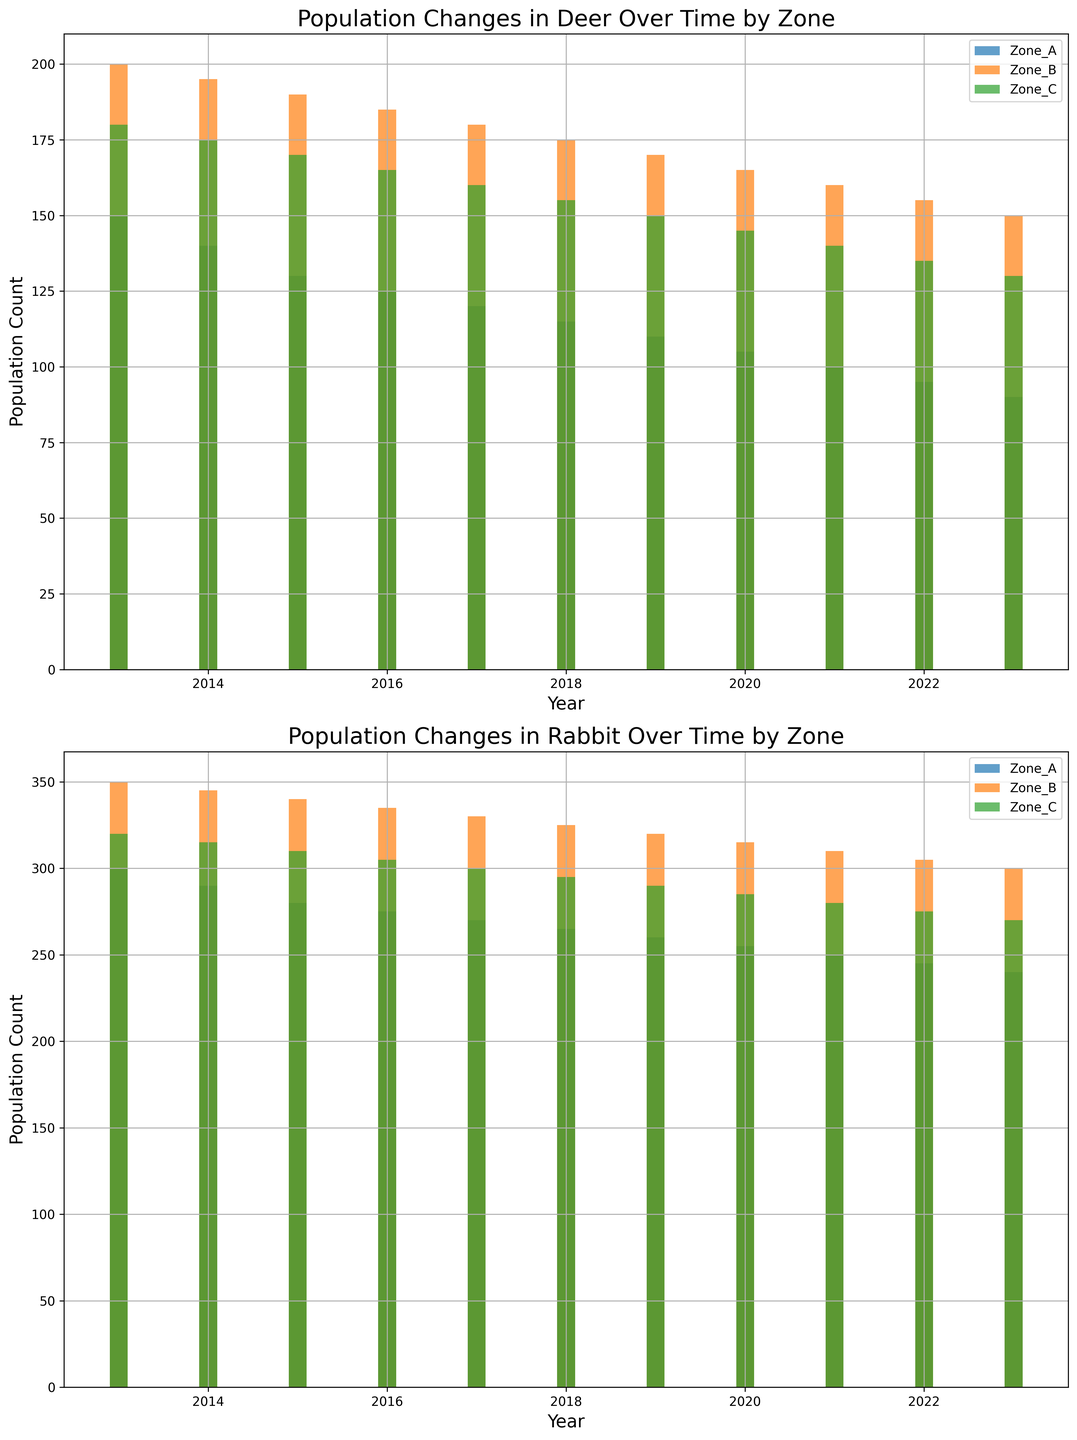What is the trend in the deer population in Zone A over the 10-year period? To determine the trend, we look at the bar heights for Zone A over the 10-year period from 2013 to 2023. The height of the bars decreases each year, indicating a consistent downward trend in the deer population.
Answer: Downward trend How does the rabbit population in Zone B in 2023 compare to that in 2013? By comparing the bar heights for the rabbit population in Zone B in 2013 and 2023, we see that the height of the bar in 2023 (300) is slightly lower than that in 2013 (350), indicating a decrease.
Answer: Decreased Which industrial zone has the highest population count for deer in 2020? By looking at the height of the bars for deer in all three zones for the year 2020, Zone B has the highest bar, indicating it has the highest population count.
Answer: Zone B What is the average population count of rabbits in Zone A over the 10-year period? Add all the population counts for rabbits in Zone A from 2013 to 2023, then divide by the number of years (10): (300+290+280+275+270+265+260+255+250+245+240)/11 = 2700 / 11 = 245.45
Answer: 272.5 Has the deer population in Zone C ever increased from one year to the next? We look at the bar heights for deer in Zone C from each year to the next. They consistently decrease, indicating that the population has not increased from one year to the next.
Answer: No Which species in Zone B had a greater decrease in population count over the 10-year period? Calculate the difference in starting (2013) and ending (2023) counts for deer and rabbits in Zone B. For deer: 200 - 150 = 50; for rabbits: 350 - 300 = 50. Both species in Zone B had an equal decrease of 50 in their population counts.
Answer: Deer and Rabbit (equal decrease) How did the population counts for deer change across all zones from 2013 to 2023? Combining the population counts of deer for each year across all three zones for 2013 and 2023, respectively: 150+200+180 = 530 (2013) and 90+150+130 = 370 (2023). The deer population decreased by 530 - 370 = 160.
Answer: Decreased by 160 Are there any years where the population counts for deer in Zone B and Zone C were equal? Compare the heights of the bars for deer in both zones for each year. There aren't any years where the bars (population counts) are equal.
Answer: No Which species and zone combination shows the least population decrease over the 10 years? Calculate the initial and final counts and find the difference for all combinations. The smallest decrease over 10 years is seen in rabbit, Zone A: 300 - 240 = 60.
Answer: Rabbit, Zone A What is the difference in population count for rabbits in Zone C between the highest and lowest years? Identify the highest and lowest population count years for rabbits in Zone C. The highest is 2013 (320) and the lowest is 2023 (270). The difference is 320 - 270 = 50.
Answer: 50 